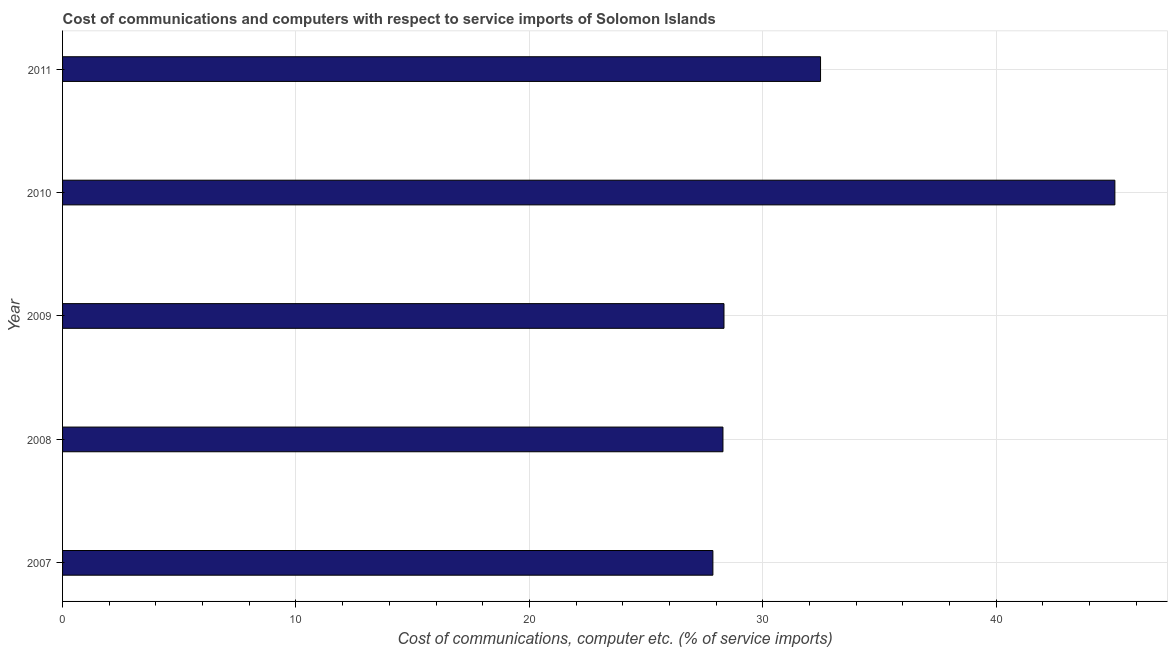What is the title of the graph?
Your answer should be very brief. Cost of communications and computers with respect to service imports of Solomon Islands. What is the label or title of the X-axis?
Your answer should be very brief. Cost of communications, computer etc. (% of service imports). What is the cost of communications and computer in 2008?
Your response must be concise. 28.29. Across all years, what is the maximum cost of communications and computer?
Provide a short and direct response. 45.08. Across all years, what is the minimum cost of communications and computer?
Offer a terse response. 27.86. What is the sum of the cost of communications and computer?
Your response must be concise. 162.04. What is the difference between the cost of communications and computer in 2008 and 2010?
Provide a succinct answer. -16.79. What is the average cost of communications and computer per year?
Make the answer very short. 32.41. What is the median cost of communications and computer?
Your answer should be compact. 28.34. In how many years, is the cost of communications and computer greater than 12 %?
Provide a succinct answer. 5. Do a majority of the years between 2008 and 2007 (inclusive) have cost of communications and computer greater than 24 %?
Offer a very short reply. No. What is the ratio of the cost of communications and computer in 2008 to that in 2011?
Make the answer very short. 0.87. Is the cost of communications and computer in 2009 less than that in 2011?
Your answer should be compact. Yes. What is the difference between the highest and the second highest cost of communications and computer?
Your answer should be compact. 12.61. What is the difference between the highest and the lowest cost of communications and computer?
Your response must be concise. 17.22. How many bars are there?
Give a very brief answer. 5. How many years are there in the graph?
Offer a terse response. 5. What is the Cost of communications, computer etc. (% of service imports) in 2007?
Provide a succinct answer. 27.86. What is the Cost of communications, computer etc. (% of service imports) in 2008?
Your answer should be very brief. 28.29. What is the Cost of communications, computer etc. (% of service imports) in 2009?
Your answer should be compact. 28.34. What is the Cost of communications, computer etc. (% of service imports) in 2010?
Keep it short and to the point. 45.08. What is the Cost of communications, computer etc. (% of service imports) of 2011?
Offer a terse response. 32.47. What is the difference between the Cost of communications, computer etc. (% of service imports) in 2007 and 2008?
Your response must be concise. -0.43. What is the difference between the Cost of communications, computer etc. (% of service imports) in 2007 and 2009?
Provide a succinct answer. -0.47. What is the difference between the Cost of communications, computer etc. (% of service imports) in 2007 and 2010?
Your response must be concise. -17.22. What is the difference between the Cost of communications, computer etc. (% of service imports) in 2007 and 2011?
Ensure brevity in your answer.  -4.61. What is the difference between the Cost of communications, computer etc. (% of service imports) in 2008 and 2009?
Ensure brevity in your answer.  -0.04. What is the difference between the Cost of communications, computer etc. (% of service imports) in 2008 and 2010?
Offer a terse response. -16.79. What is the difference between the Cost of communications, computer etc. (% of service imports) in 2008 and 2011?
Give a very brief answer. -4.18. What is the difference between the Cost of communications, computer etc. (% of service imports) in 2009 and 2010?
Your response must be concise. -16.75. What is the difference between the Cost of communications, computer etc. (% of service imports) in 2009 and 2011?
Your response must be concise. -4.14. What is the difference between the Cost of communications, computer etc. (% of service imports) in 2010 and 2011?
Offer a very short reply. 12.61. What is the ratio of the Cost of communications, computer etc. (% of service imports) in 2007 to that in 2008?
Provide a succinct answer. 0.98. What is the ratio of the Cost of communications, computer etc. (% of service imports) in 2007 to that in 2010?
Keep it short and to the point. 0.62. What is the ratio of the Cost of communications, computer etc. (% of service imports) in 2007 to that in 2011?
Ensure brevity in your answer.  0.86. What is the ratio of the Cost of communications, computer etc. (% of service imports) in 2008 to that in 2010?
Your answer should be very brief. 0.63. What is the ratio of the Cost of communications, computer etc. (% of service imports) in 2008 to that in 2011?
Your answer should be very brief. 0.87. What is the ratio of the Cost of communications, computer etc. (% of service imports) in 2009 to that in 2010?
Offer a very short reply. 0.63. What is the ratio of the Cost of communications, computer etc. (% of service imports) in 2009 to that in 2011?
Your response must be concise. 0.87. What is the ratio of the Cost of communications, computer etc. (% of service imports) in 2010 to that in 2011?
Provide a succinct answer. 1.39. 